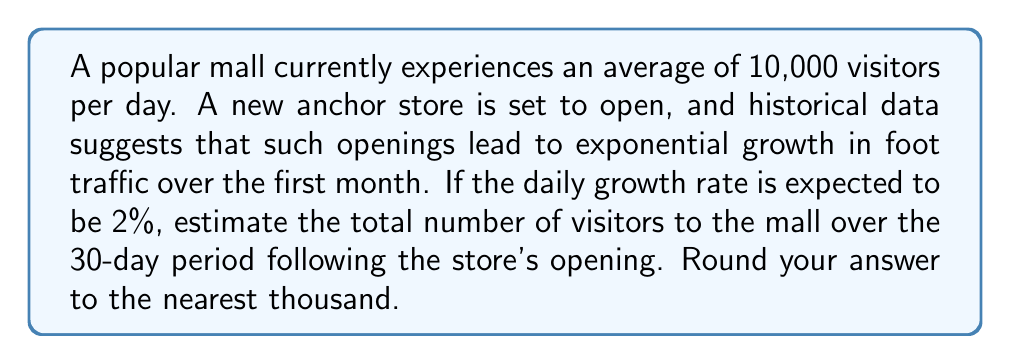Help me with this question. Let's approach this step-by-step using an exponential growth model:

1) The initial number of visitors per day is 10,000.
2) The daily growth rate is 2% or 0.02.
3) We need to calculate the sum of visitors over 30 days.

Let $V_n$ be the number of visitors on day $n$. The exponential growth model is:

$$V_n = 10000 \cdot (1.02)^n$$

To find the total number of visitors over 30 days, we need to sum this from $n=0$ to $n=29$:

$$\text{Total Visitors} = \sum_{n=0}^{29} 10000 \cdot (1.02)^n$$

This is a geometric series with first term $a=10000$ and common ratio $r=1.02$.
The sum of a geometric series is given by:

$$S_n = a\frac{1-r^n}{1-r}, \text{ where } n=30$$

Substituting our values:

$$\text{Total Visitors} = 10000 \cdot \frac{1-(1.02)^{30}}{1-1.02}$$

$$= 10000 \cdot \frac{1-1.8114}{-0.02}$$

$$= 10000 \cdot \frac{-0.8114}{-0.02}$$

$$= 10000 \cdot 40.57$$

$$= 405,700$$

Rounding to the nearest thousand:

$$\text{Total Visitors} \approx 406,000$$
Answer: 406,000 visitors 